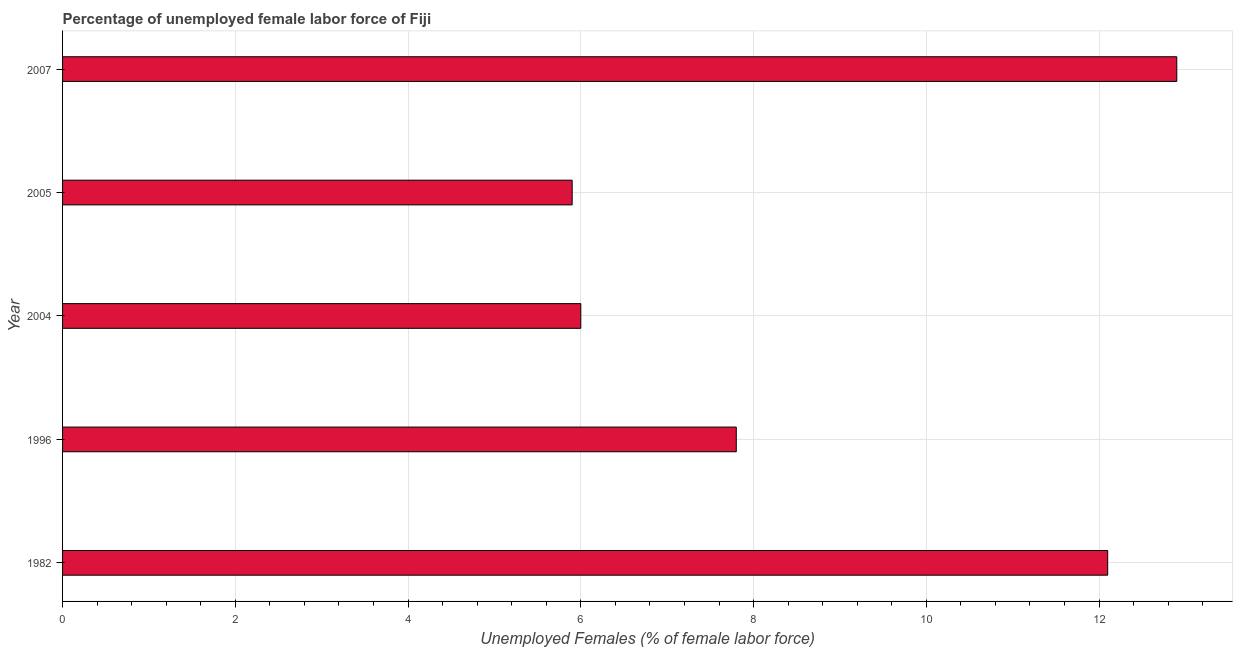Does the graph contain any zero values?
Your answer should be compact. No. Does the graph contain grids?
Your response must be concise. Yes. What is the title of the graph?
Your response must be concise. Percentage of unemployed female labor force of Fiji. What is the label or title of the X-axis?
Your answer should be compact. Unemployed Females (% of female labor force). What is the label or title of the Y-axis?
Keep it short and to the point. Year. What is the total unemployed female labour force in 1982?
Your response must be concise. 12.1. Across all years, what is the maximum total unemployed female labour force?
Provide a succinct answer. 12.9. Across all years, what is the minimum total unemployed female labour force?
Ensure brevity in your answer.  5.9. In which year was the total unemployed female labour force minimum?
Offer a very short reply. 2005. What is the sum of the total unemployed female labour force?
Ensure brevity in your answer.  44.7. What is the average total unemployed female labour force per year?
Keep it short and to the point. 8.94. What is the median total unemployed female labour force?
Your response must be concise. 7.8. What is the ratio of the total unemployed female labour force in 1982 to that in 2004?
Your answer should be very brief. 2.02. Is the difference between the total unemployed female labour force in 1982 and 2005 greater than the difference between any two years?
Offer a very short reply. No. What is the difference between the highest and the second highest total unemployed female labour force?
Provide a succinct answer. 0.8. What is the difference between the highest and the lowest total unemployed female labour force?
Offer a terse response. 7. In how many years, is the total unemployed female labour force greater than the average total unemployed female labour force taken over all years?
Your response must be concise. 2. What is the difference between two consecutive major ticks on the X-axis?
Provide a short and direct response. 2. What is the Unemployed Females (% of female labor force) in 1982?
Ensure brevity in your answer.  12.1. What is the Unemployed Females (% of female labor force) in 1996?
Provide a short and direct response. 7.8. What is the Unemployed Females (% of female labor force) in 2004?
Ensure brevity in your answer.  6. What is the Unemployed Females (% of female labor force) in 2005?
Offer a very short reply. 5.9. What is the Unemployed Females (% of female labor force) in 2007?
Your answer should be compact. 12.9. What is the difference between the Unemployed Females (% of female labor force) in 1982 and 1996?
Keep it short and to the point. 4.3. What is the difference between the Unemployed Females (% of female labor force) in 1996 and 2005?
Offer a terse response. 1.9. What is the difference between the Unemployed Females (% of female labor force) in 1996 and 2007?
Your response must be concise. -5.1. What is the difference between the Unemployed Females (% of female labor force) in 2004 and 2005?
Your response must be concise. 0.1. What is the difference between the Unemployed Females (% of female labor force) in 2004 and 2007?
Your response must be concise. -6.9. What is the ratio of the Unemployed Females (% of female labor force) in 1982 to that in 1996?
Offer a terse response. 1.55. What is the ratio of the Unemployed Females (% of female labor force) in 1982 to that in 2004?
Your answer should be very brief. 2.02. What is the ratio of the Unemployed Females (% of female labor force) in 1982 to that in 2005?
Keep it short and to the point. 2.05. What is the ratio of the Unemployed Females (% of female labor force) in 1982 to that in 2007?
Make the answer very short. 0.94. What is the ratio of the Unemployed Females (% of female labor force) in 1996 to that in 2004?
Ensure brevity in your answer.  1.3. What is the ratio of the Unemployed Females (% of female labor force) in 1996 to that in 2005?
Your response must be concise. 1.32. What is the ratio of the Unemployed Females (% of female labor force) in 1996 to that in 2007?
Offer a terse response. 0.6. What is the ratio of the Unemployed Females (% of female labor force) in 2004 to that in 2005?
Keep it short and to the point. 1.02. What is the ratio of the Unemployed Females (% of female labor force) in 2004 to that in 2007?
Your response must be concise. 0.47. What is the ratio of the Unemployed Females (% of female labor force) in 2005 to that in 2007?
Your answer should be compact. 0.46. 